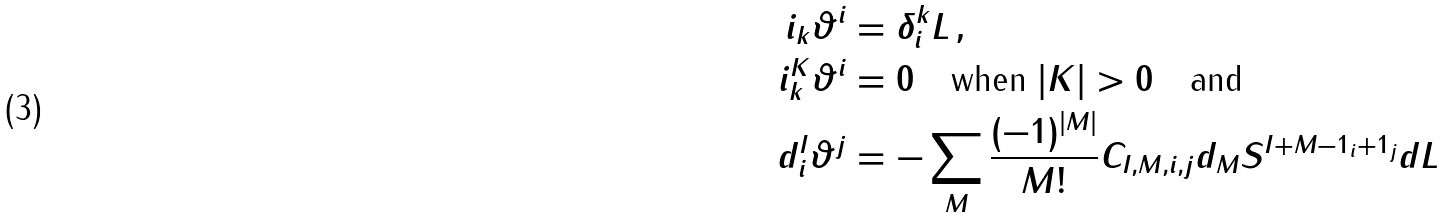<formula> <loc_0><loc_0><loc_500><loc_500>i _ { k } \vartheta ^ { i } & = \delta ^ { k } _ { i } L \, , \\ i ^ { K } _ { k } \vartheta ^ { i } & = 0 \quad \text {when $|K| > 0$} \quad \text {and} \\ d ^ { I } _ { i } \vartheta ^ { j } & = - \sum _ { M } \frac { ( - 1 ) ^ { | M | } } { M ! } C _ { I , M , i , j } d _ { M } S ^ { I + M - 1 _ { i } + 1 _ { j } } d L</formula> 